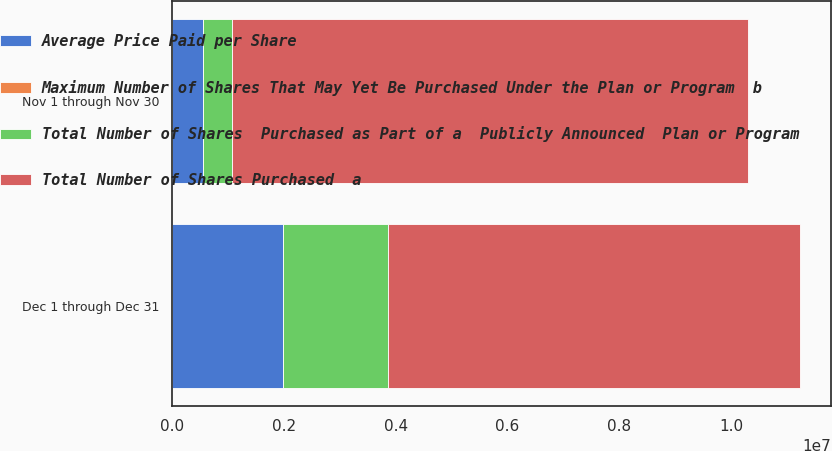<chart> <loc_0><loc_0><loc_500><loc_500><stacked_bar_chart><ecel><fcel>Nov 1 through Nov 30<fcel>Dec 1 through Dec 31<nl><fcel>Average Price Paid per Share<fcel>540294<fcel>1.98608e+06<nl><fcel>Maximum Number of Shares That May Yet Be Purchased Under the Plan or Program  b<fcel>124.7<fcel>128.53<nl><fcel>Total Number of Shares  Purchased as Part of a  Publicly Announced  Plan or Program<fcel>528000<fcel>1.8698e+06<nl><fcel>Total Number of Shares Purchased  a<fcel>9.24628e+06<fcel>7.37648e+06<nl></chart> 